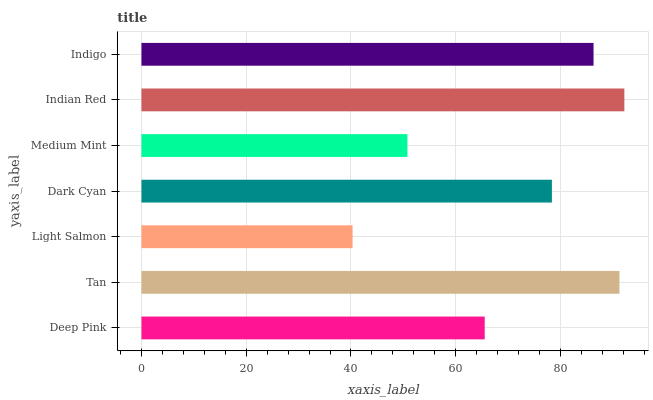Is Light Salmon the minimum?
Answer yes or no. Yes. Is Indian Red the maximum?
Answer yes or no. Yes. Is Tan the minimum?
Answer yes or no. No. Is Tan the maximum?
Answer yes or no. No. Is Tan greater than Deep Pink?
Answer yes or no. Yes. Is Deep Pink less than Tan?
Answer yes or no. Yes. Is Deep Pink greater than Tan?
Answer yes or no. No. Is Tan less than Deep Pink?
Answer yes or no. No. Is Dark Cyan the high median?
Answer yes or no. Yes. Is Dark Cyan the low median?
Answer yes or no. Yes. Is Light Salmon the high median?
Answer yes or no. No. Is Indian Red the low median?
Answer yes or no. No. 